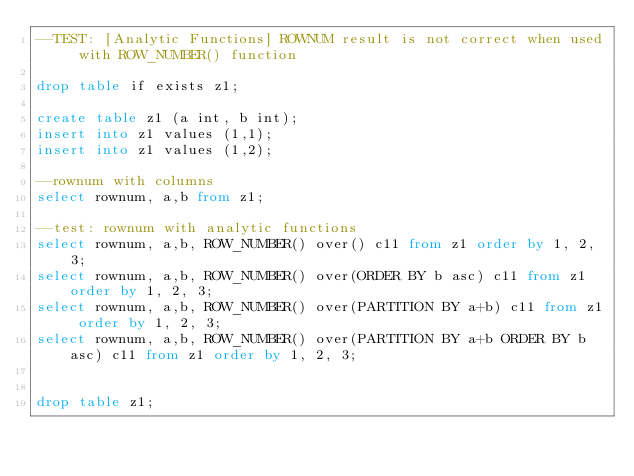Convert code to text. <code><loc_0><loc_0><loc_500><loc_500><_SQL_>--TEST: [Analytic Functions] ROWNUM result is not correct when used with ROW_NUMBER() function

drop table if exists z1;

create table z1 (a int, b int);
insert into z1 values (1,1);
insert into z1 values (1,2);

--rownum with columns
select rownum, a,b from z1;

--test: rownum with analytic functions
select rownum, a,b, ROW_NUMBER() over() c11 from z1 order by 1, 2, 3;
select rownum, a,b, ROW_NUMBER() over(ORDER BY b asc) c11 from z1 order by 1, 2, 3;
select rownum, a,b, ROW_NUMBER() over(PARTITION BY a+b) c11 from z1 order by 1, 2, 3;
select rownum, a,b, ROW_NUMBER() over(PARTITION BY a+b ORDER BY b asc) c11 from z1 order by 1, 2, 3;


drop table z1;
</code> 